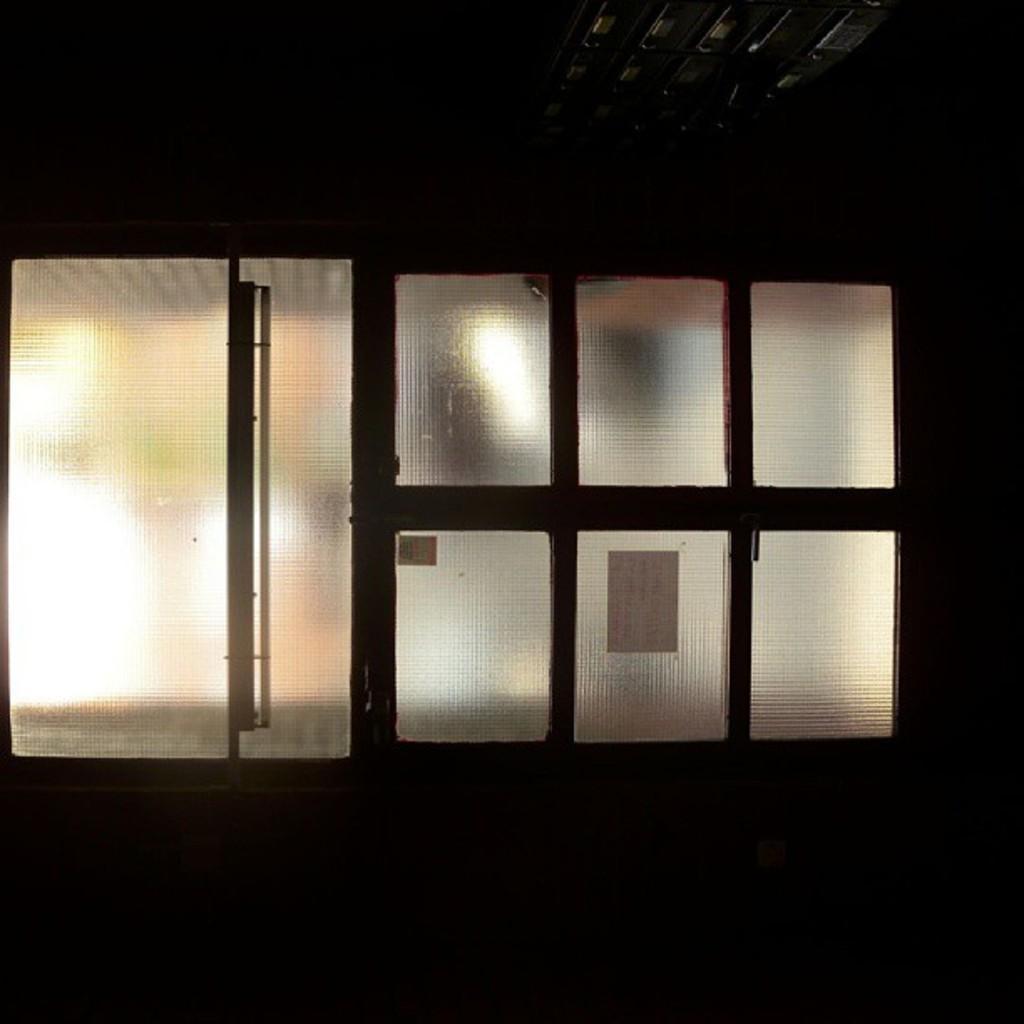Could you give a brief overview of what you see in this image? In the center of the image there is a wall,roof,glass,glass door,posters,lights and few other objects. 